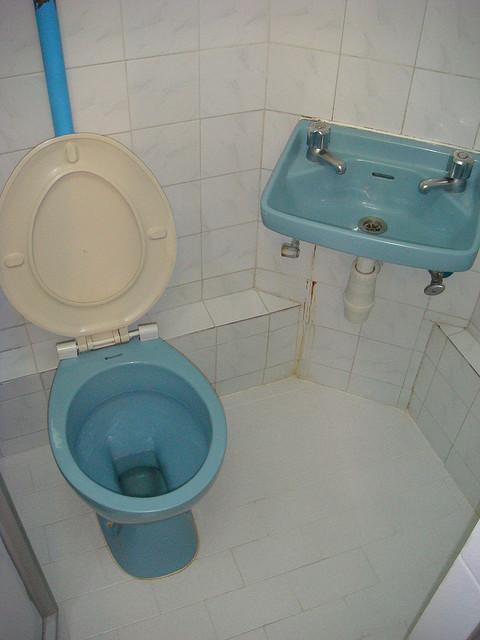How many chairs are at the table?
Give a very brief answer. 0. 